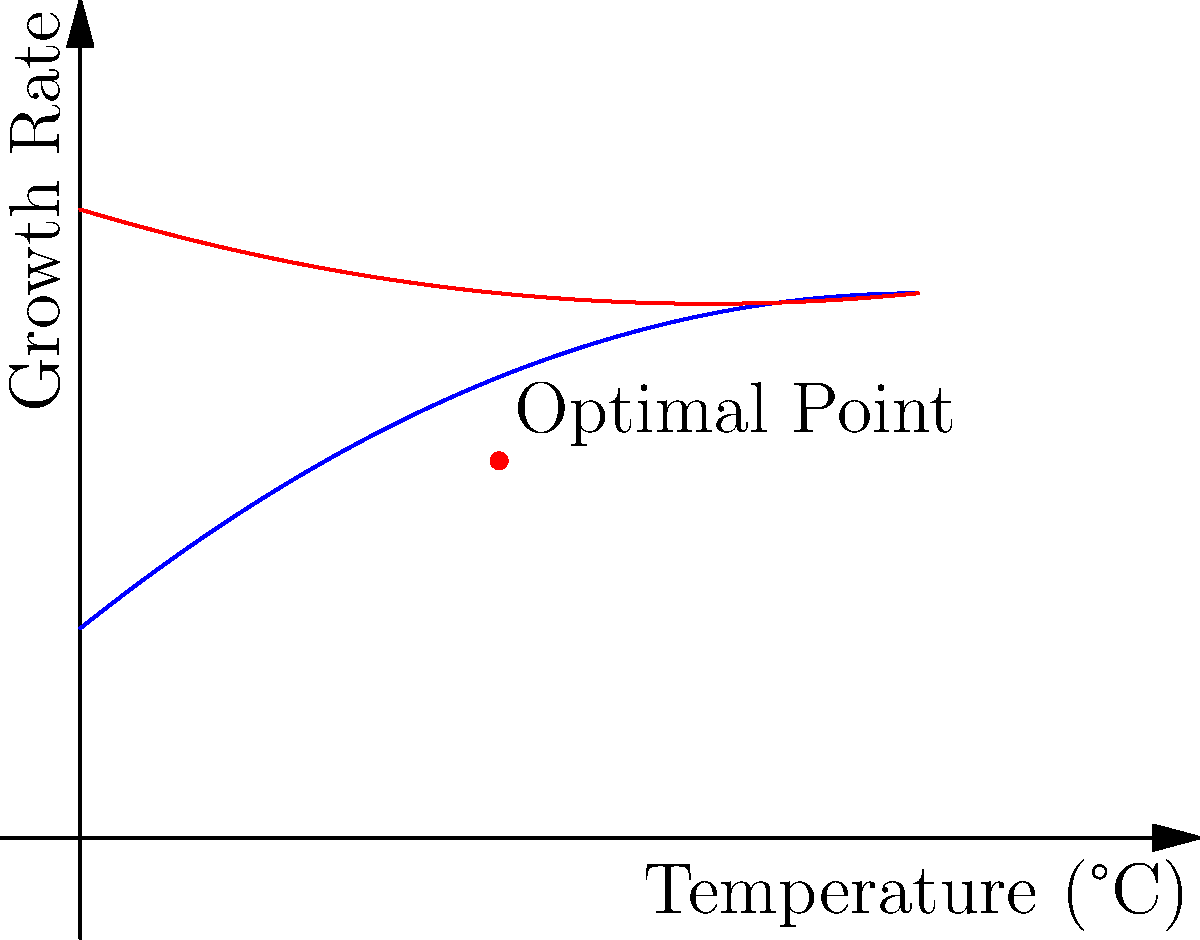Given the growth rate curves for Trichothelium rubellum as functions of temperature, where blue represents temperature and red represents humidity:

Temperature: $f(x) = -0.01x^2 + 0.8x + 10$
Humidity: $g(x) = 0.005x^2 - 0.3x + 30$

Where $x$ is the temperature in °C and $y$ is the growth rate.

Determine the optimal temperature for Trichothelium rubellum growth by finding the point where the derivative of the temperature function equals zero. Then, calculate the corresponding humidity at this optimal temperature. 1. To find the optimal temperature, we need to find where the derivative of $f(x)$ equals zero:

   $f'(x) = -0.02x + 0.8$
   Set $f'(x) = 0$:
   $-0.02x + 0.8 = 0$
   $-0.02x = -0.8$
   $x = 40$

2. The optimal temperature is 40°C.

3. To find the corresponding humidity, we plug x = 40 into the humidity function $g(x)$:

   $g(40) = 0.005(40)^2 - 0.3(40) + 30$
   $= 0.005(1600) - 12 + 30$
   $= 8 - 12 + 30$
   $= 26$

4. Therefore, at the optimal temperature of 40°C, the corresponding humidity is 26%.
Answer: Optimal temperature: 40°C; Corresponding humidity: 26% 